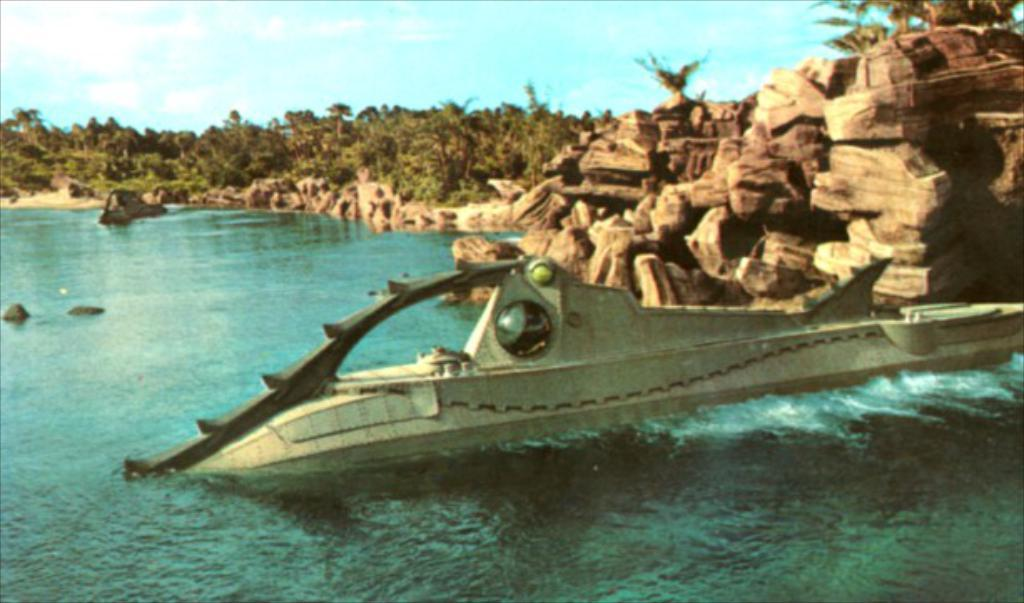What type of natural environment is depicted in the image? The image features many trees, plants, and a lake, indicating a natural environment. Can you describe the terrain in the image? The terrain includes rocks, which suggests a rocky or hilly landscape. What is present in the water in the image? There is an object in the water, but its nature is not specified. What is visible in the sky in the image? The sky is visible in the image, but no specific details about its appearance are provided. What type of cheese can be seen hanging from the trees in the image? There is no cheese present in the image; it features trees, plants, rocks, a lake, and an object in the water. 